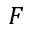Convert formula to latex. <formula><loc_0><loc_0><loc_500><loc_500>F</formula> 